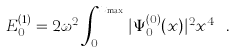Convert formula to latex. <formula><loc_0><loc_0><loc_500><loc_500>E ^ { ( 1 ) } _ { 0 } = 2 \omega ^ { 2 } \int _ { 0 } ^ { x _ { \max } } | \Psi _ { 0 } ^ { ( 0 ) } ( x ) | ^ { 2 } x ^ { 4 } \ .</formula> 